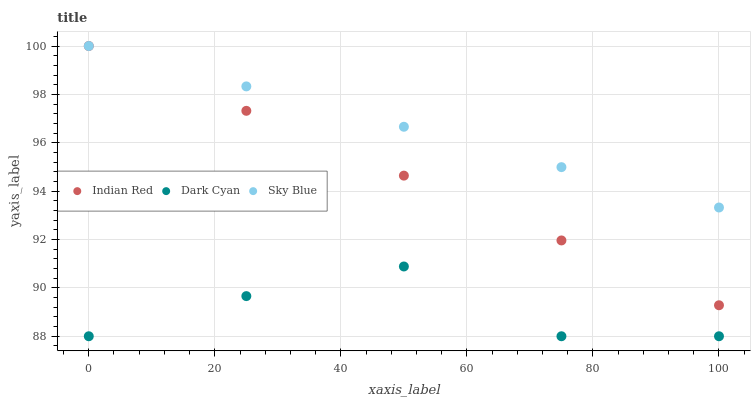Does Dark Cyan have the minimum area under the curve?
Answer yes or no. Yes. Does Sky Blue have the maximum area under the curve?
Answer yes or no. Yes. Does Indian Red have the minimum area under the curve?
Answer yes or no. No. Does Indian Red have the maximum area under the curve?
Answer yes or no. No. Is Sky Blue the smoothest?
Answer yes or no. Yes. Is Dark Cyan the roughest?
Answer yes or no. Yes. Is Indian Red the smoothest?
Answer yes or no. No. Is Indian Red the roughest?
Answer yes or no. No. Does Dark Cyan have the lowest value?
Answer yes or no. Yes. Does Indian Red have the lowest value?
Answer yes or no. No. Does Indian Red have the highest value?
Answer yes or no. Yes. Is Dark Cyan less than Indian Red?
Answer yes or no. Yes. Is Sky Blue greater than Dark Cyan?
Answer yes or no. Yes. Does Indian Red intersect Sky Blue?
Answer yes or no. Yes. Is Indian Red less than Sky Blue?
Answer yes or no. No. Is Indian Red greater than Sky Blue?
Answer yes or no. No. Does Dark Cyan intersect Indian Red?
Answer yes or no. No. 